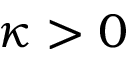Convert formula to latex. <formula><loc_0><loc_0><loc_500><loc_500>\kappa > 0</formula> 